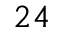Convert formula to latex. <formula><loc_0><loc_0><loc_500><loc_500>^ { 2 4 }</formula> 